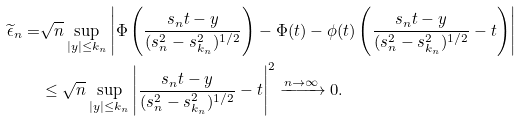Convert formula to latex. <formula><loc_0><loc_0><loc_500><loc_500>\widetilde { \epsilon } _ { n } = & \sqrt { n } \sup _ { | y | \leq k _ { n } } \left | \Phi \left ( \frac { s _ { n } t - y } { ( s _ { n } ^ { 2 } - s _ { k _ { n } } ^ { 2 } ) ^ { 1 / 2 } } \right ) - \Phi ( t ) - \phi ( t ) \left ( \frac { s _ { n } t - y } { ( s _ { n } ^ { 2 } - s _ { k _ { n } } ^ { 2 } ) ^ { 1 / 2 } } - t \right ) \right | \\ & \leq \sqrt { n } \sup _ { | y | \leq k _ { n } } \left | \frac { s _ { n } t - y } { ( s _ { n } ^ { 2 } - s _ { k _ { n } } ^ { 2 } ) ^ { 1 / 2 } } - t \right | ^ { 2 } \xrightarrow { n \rightarrow \infty } 0 .</formula> 